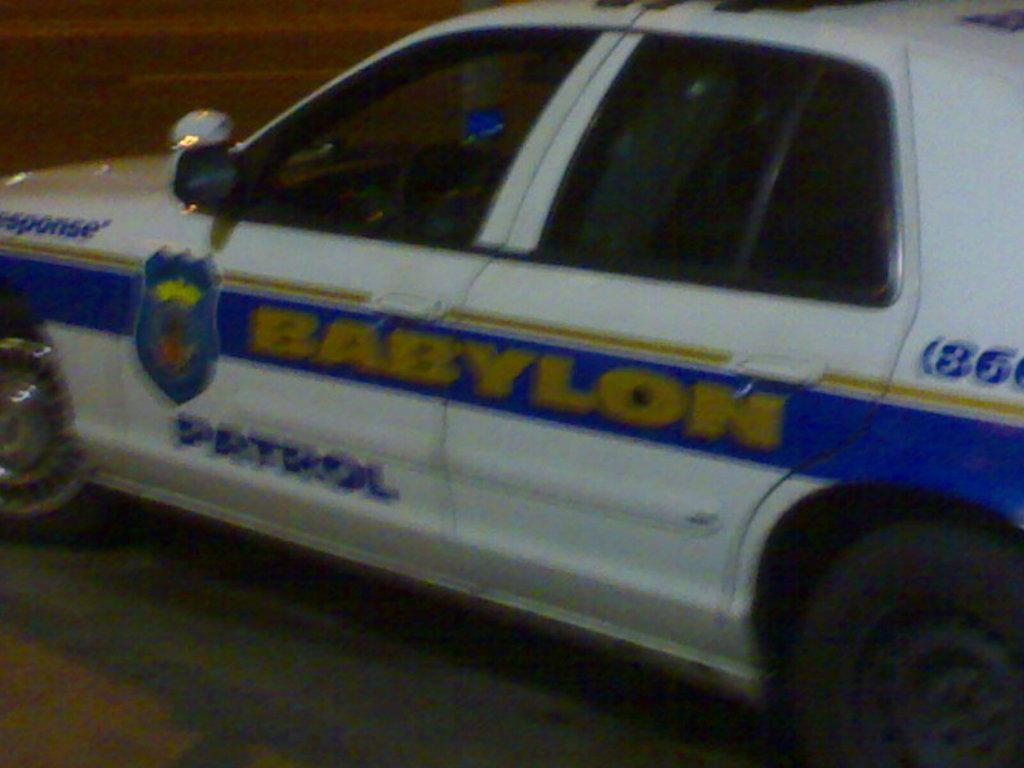<image>
Write a terse but informative summary of the picture. A white vehicle with the word Patrol on it in blue. 